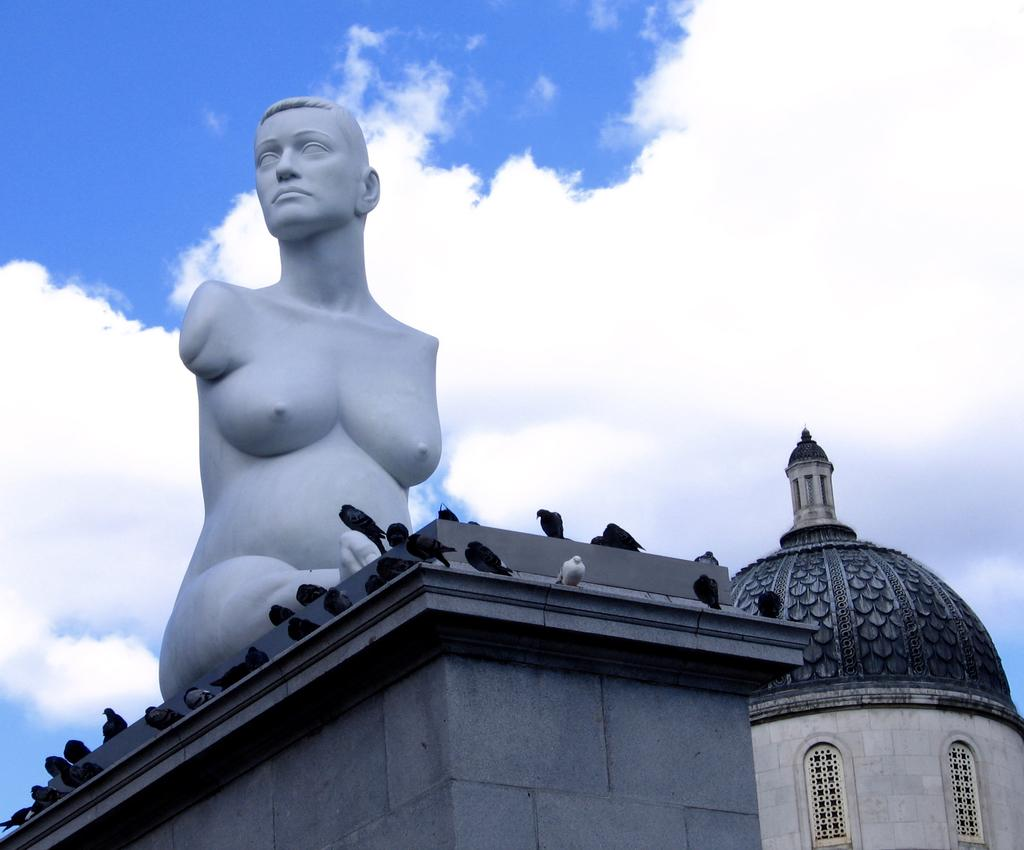What type of statue is present in the image? There is a woman statue in the image. What other living creatures can be seen in the image? There are birds in the image. What type of structure is visible in the image? There is a tower in the image. What architectural element is present in the image? There is a wall in the image. How would you describe the weather in the image? The sky is cloudy in the image. What type of substance is the zebra using to clean the kittens in the image? There is no zebra or kittens present in the image, so this question cannot be answered. 